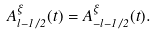<formula> <loc_0><loc_0><loc_500><loc_500>A _ { l - 1 / 2 } ^ { \xi } ( t ) = A _ { - l - 1 / 2 } ^ { \xi } ( t ) .</formula> 